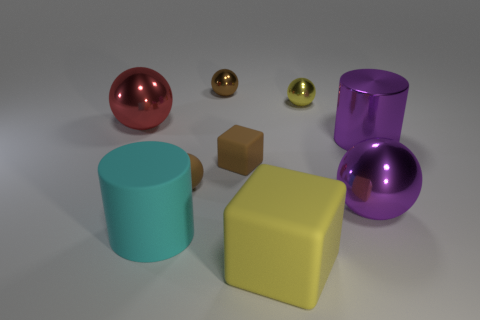What is the small brown object behind the large ball that is to the left of the big yellow object made of?
Your response must be concise. Metal. Does the big purple thing that is left of the purple metal cylinder have the same shape as the small rubber object behind the rubber sphere?
Keep it short and to the point. No. What is the size of the rubber object that is both on the left side of the brown shiny object and to the right of the big cyan object?
Keep it short and to the point. Small. How many other objects are there of the same color as the big cube?
Your answer should be very brief. 1. Are the big object that is on the left side of the large matte cylinder and the big purple cylinder made of the same material?
Keep it short and to the point. Yes. Is the number of big metal cylinders that are on the right side of the cyan matte thing less than the number of small yellow metal spheres to the left of the brown metal object?
Offer a very short reply. No. There is a cube that is the same color as the rubber sphere; what is it made of?
Your response must be concise. Rubber. There is a big cylinder that is in front of the purple thing that is behind the large purple ball; what number of matte cubes are behind it?
Your answer should be very brief. 1. How many brown things are on the right side of the large cyan cylinder?
Provide a succinct answer. 3. How many brown balls have the same material as the large red object?
Provide a succinct answer. 1. 